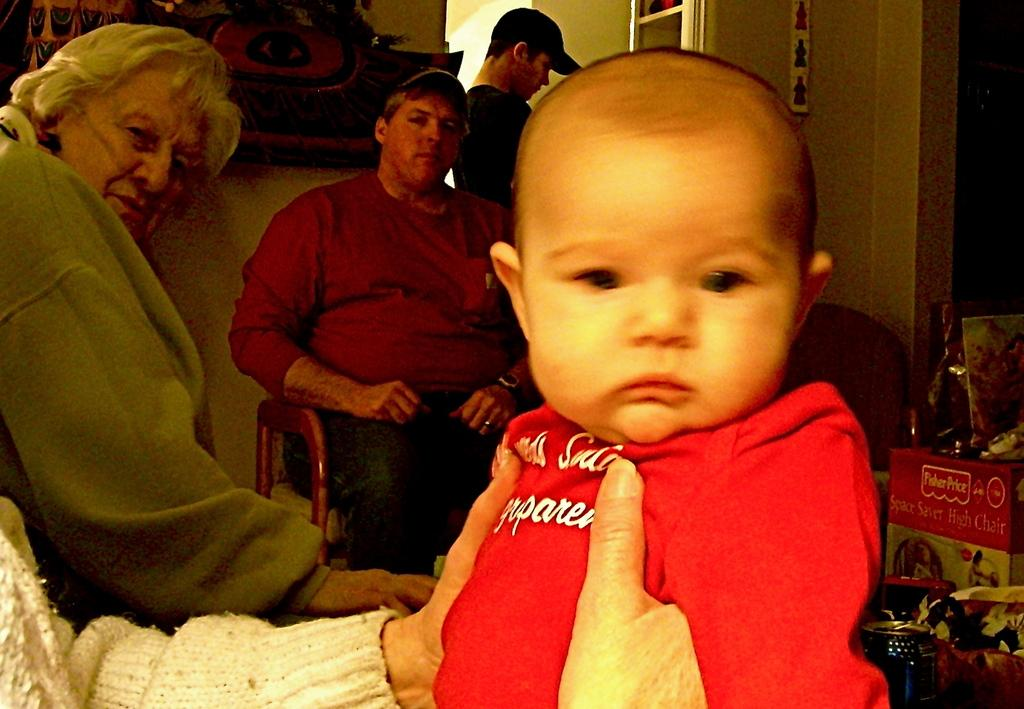How many people are in the image? There is a group of people in the image. Can you describe the clothing of one person in the group? One person in the group is wearing a red shirt. What can be seen on the wall in the background? There are objects attached to the wall in the background. What color is the wall in the background? The wall in the background is cream-colored. What type of spark can be seen coming from the person wearing the red shirt in the image? There is no spark visible in the image, and the person wearing the red shirt is not generating any sparks. 